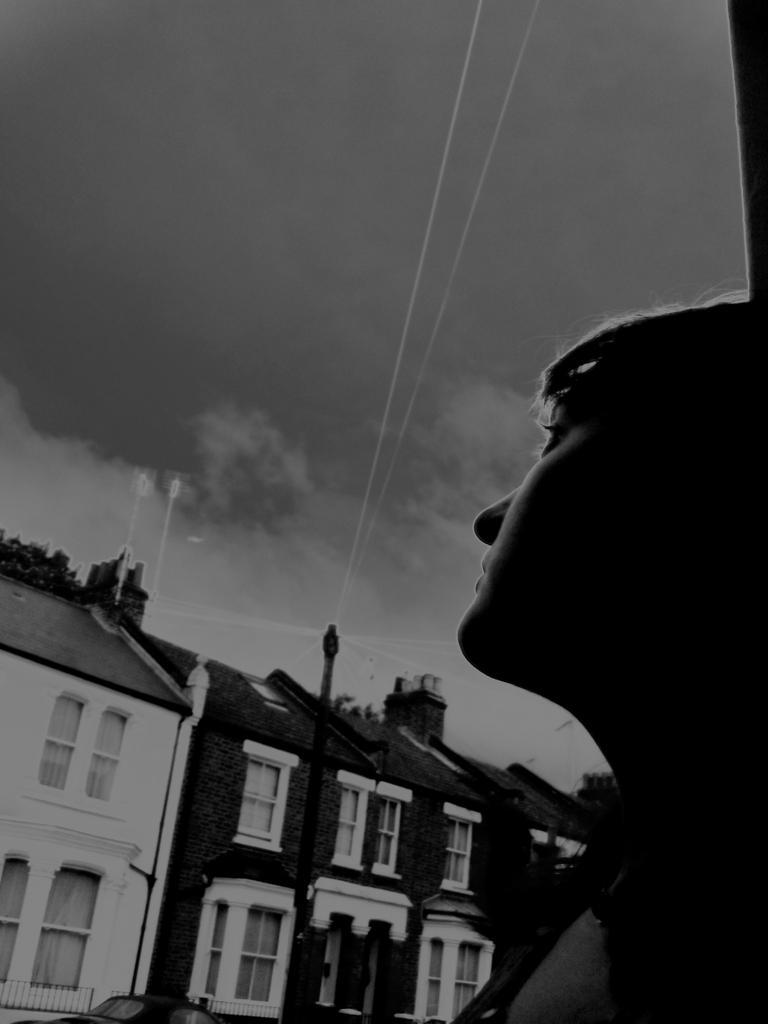In one or two sentences, can you explain what this image depicts? In front of the image there is a person, behind the person there are trees, buildings and a lamp post, in front of the building there is a car, at the top of the image there are clouds in the sky. 